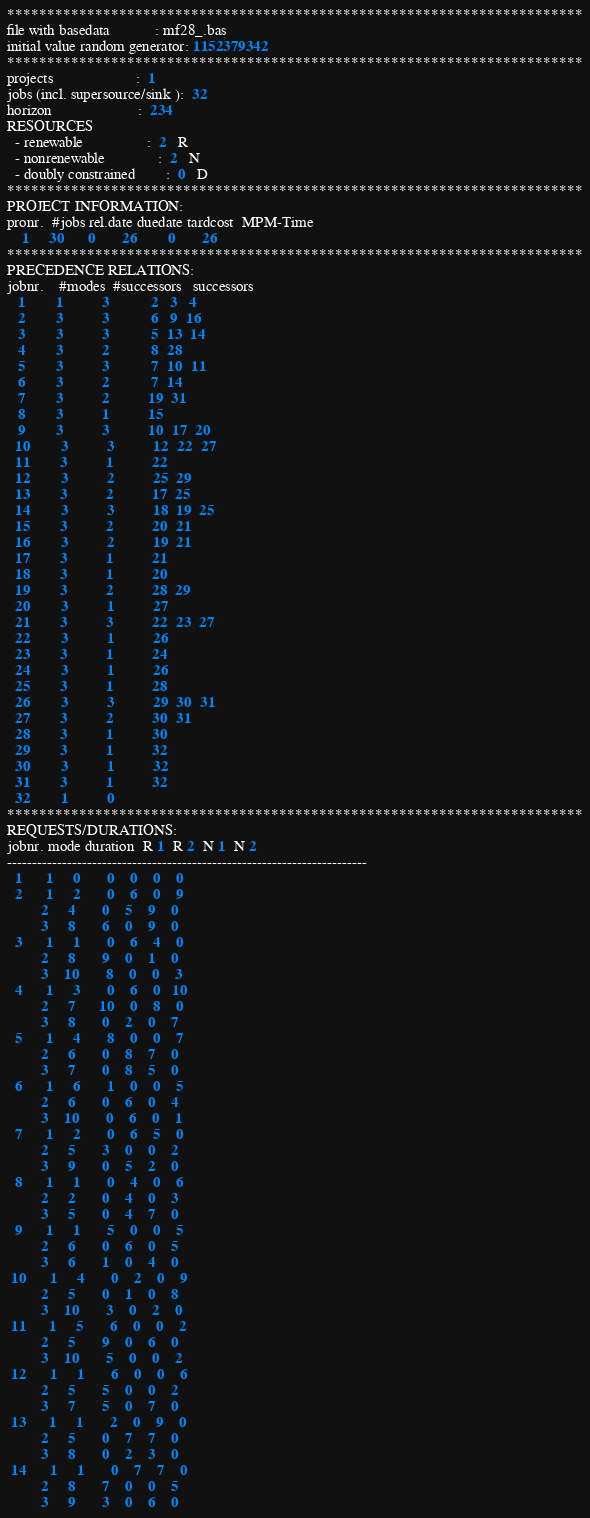Convert code to text. <code><loc_0><loc_0><loc_500><loc_500><_ObjectiveC_>************************************************************************
file with basedata            : mf28_.bas
initial value random generator: 1152379342
************************************************************************
projects                      :  1
jobs (incl. supersource/sink ):  32
horizon                       :  234
RESOURCES
  - renewable                 :  2   R
  - nonrenewable              :  2   N
  - doubly constrained        :  0   D
************************************************************************
PROJECT INFORMATION:
pronr.  #jobs rel.date duedate tardcost  MPM-Time
    1     30      0       26        0       26
************************************************************************
PRECEDENCE RELATIONS:
jobnr.    #modes  #successors   successors
   1        1          3           2   3   4
   2        3          3           6   9  16
   3        3          3           5  13  14
   4        3          2           8  28
   5        3          3           7  10  11
   6        3          2           7  14
   7        3          2          19  31
   8        3          1          15
   9        3          3          10  17  20
  10        3          3          12  22  27
  11        3          1          22
  12        3          2          25  29
  13        3          2          17  25
  14        3          3          18  19  25
  15        3          2          20  21
  16        3          2          19  21
  17        3          1          21
  18        3          1          20
  19        3          2          28  29
  20        3          1          27
  21        3          3          22  23  27
  22        3          1          26
  23        3          1          24
  24        3          1          26
  25        3          1          28
  26        3          3          29  30  31
  27        3          2          30  31
  28        3          1          30
  29        3          1          32
  30        3          1          32
  31        3          1          32
  32        1          0        
************************************************************************
REQUESTS/DURATIONS:
jobnr. mode duration  R 1  R 2  N 1  N 2
------------------------------------------------------------------------
  1      1     0       0    0    0    0
  2      1     2       0    6    0    9
         2     4       0    5    9    0
         3     8       6    0    9    0
  3      1     1       0    6    4    0
         2     8       9    0    1    0
         3    10       8    0    0    3
  4      1     3       0    6    0   10
         2     7      10    0    8    0
         3     8       0    2    0    7
  5      1     4       8    0    0    7
         2     6       0    8    7    0
         3     7       0    8    5    0
  6      1     6       1    0    0    5
         2     6       0    6    0    4
         3    10       0    6    0    1
  7      1     2       0    6    5    0
         2     5       3    0    0    2
         3     9       0    5    2    0
  8      1     1       0    4    0    6
         2     2       0    4    0    3
         3     5       0    4    7    0
  9      1     1       5    0    0    5
         2     6       0    6    0    5
         3     6       1    0    4    0
 10      1     4       0    2    0    9
         2     5       0    1    0    8
         3    10       3    0    2    0
 11      1     5       6    0    0    2
         2     5       9    0    6    0
         3    10       5    0    0    2
 12      1     1       6    0    0    6
         2     5       5    0    0    2
         3     7       5    0    7    0
 13      1     1       2    0    9    0
         2     5       0    7    7    0
         3     8       0    2    3    0
 14      1     1       0    7    7    0
         2     8       7    0    0    5
         3     9       3    0    6    0</code> 